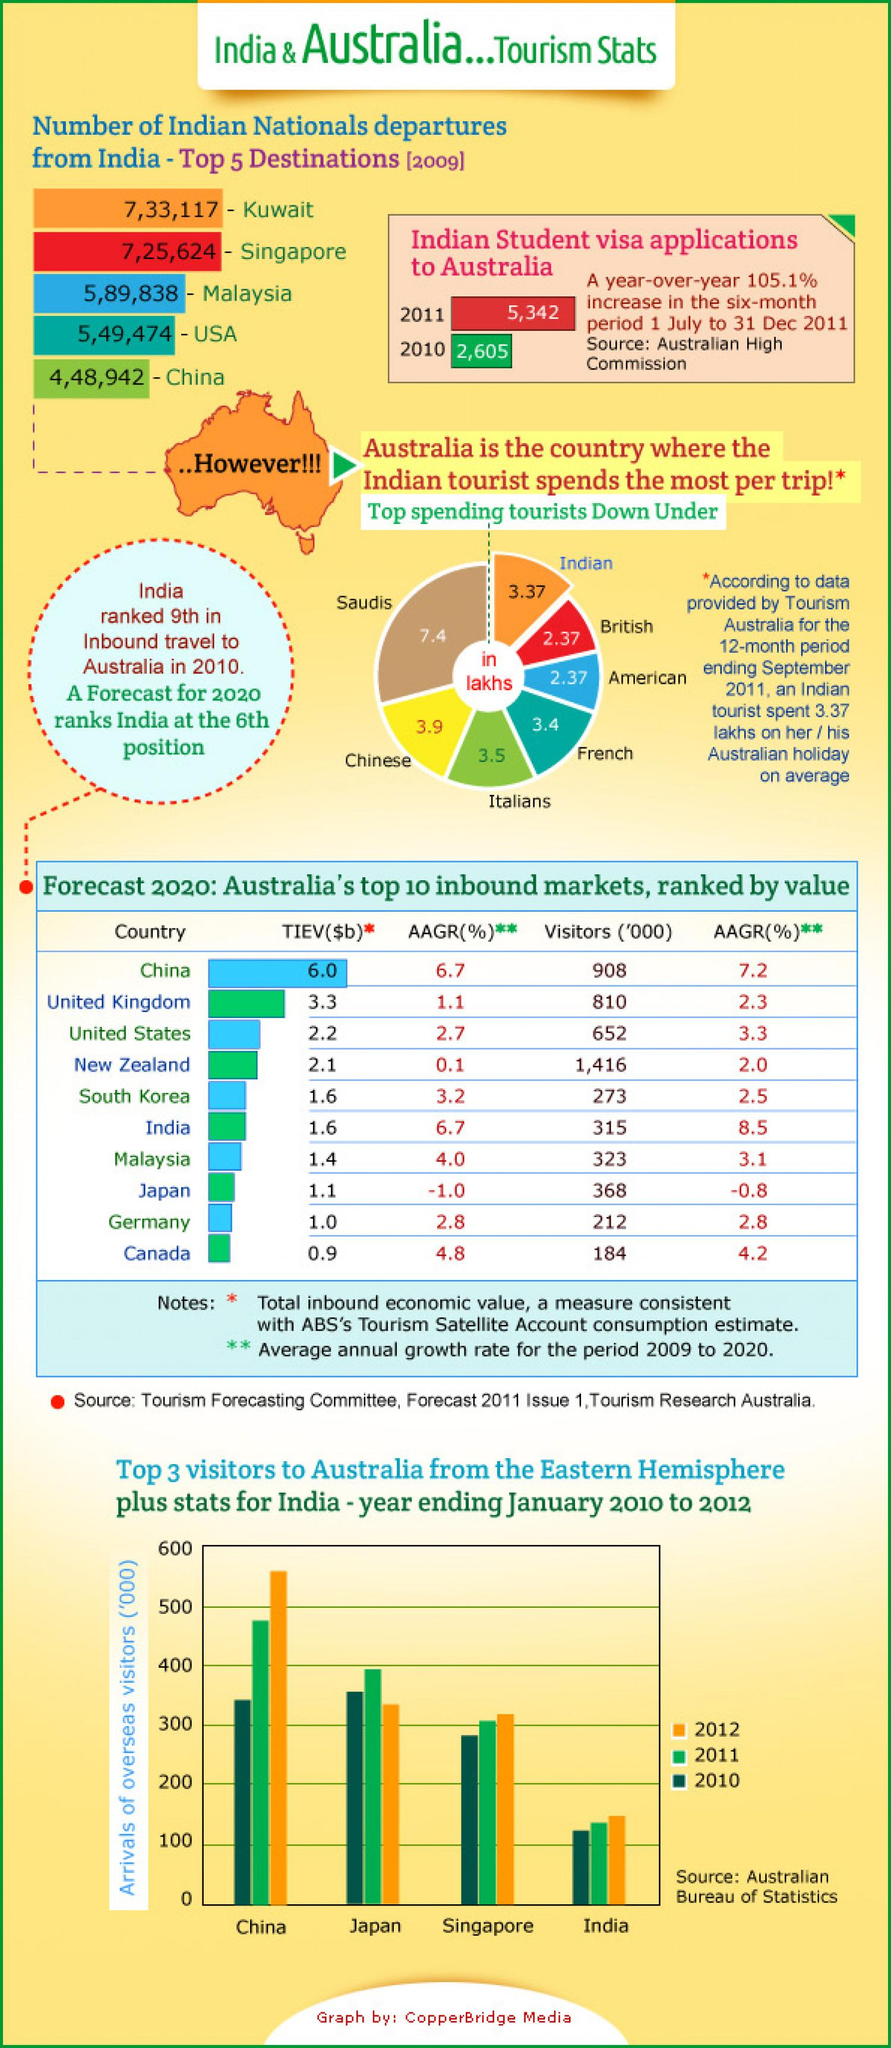Mention a couple of crucial points in this snapshot. In 2011, Japan was the second top visitor to Australia from the eastern hemisphere. According to the forecast for 2020, China is expected to have the second highest number of visitors. There were 131,5462 departures for Indian nationals to Singapore and Malaysia during a specific time period. The increase in the six-month period was 105.1%. According to a recent survey, Indian and British tourists in Australia on average spend 5.74lakhs on their vacation. 